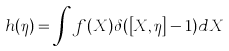Convert formula to latex. <formula><loc_0><loc_0><loc_500><loc_500>h ( \eta ) = \int f ( X ) \delta ( \left [ X , \eta \right ] - 1 ) d X</formula> 